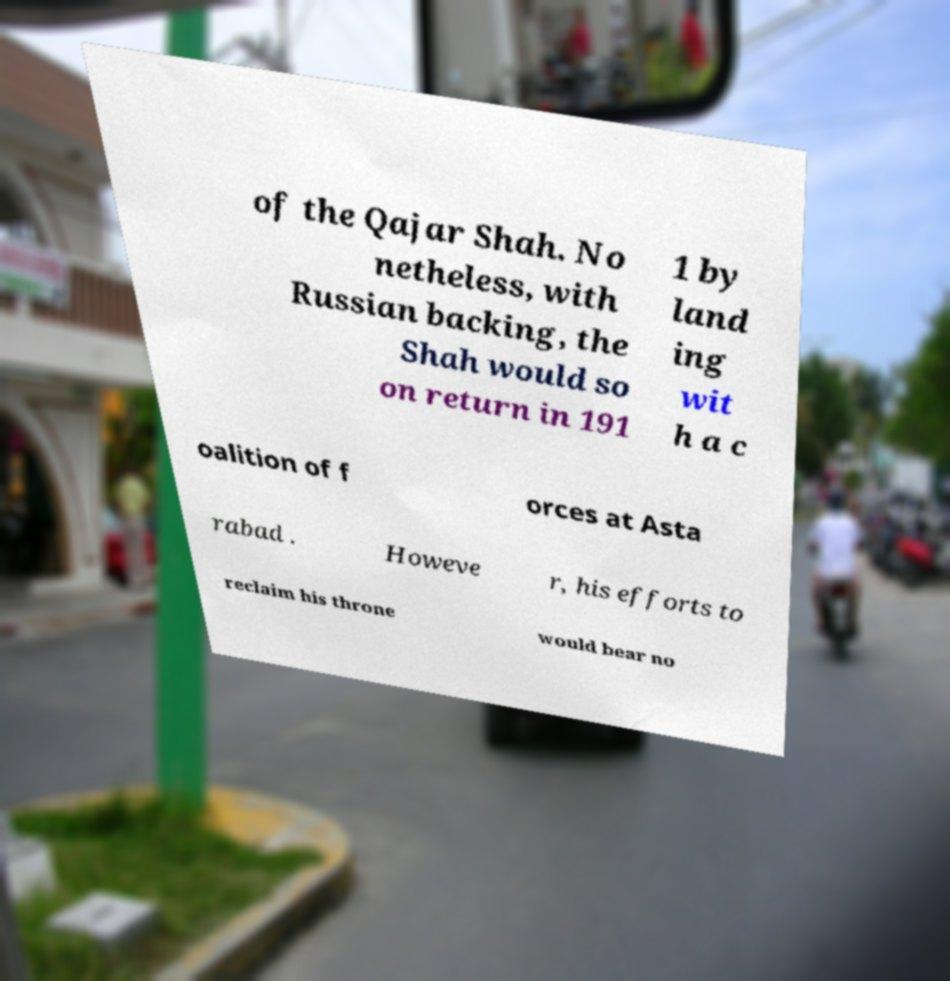Please read and relay the text visible in this image. What does it say? of the Qajar Shah. No netheless, with Russian backing, the Shah would so on return in 191 1 by land ing wit h a c oalition of f orces at Asta rabad . Howeve r, his efforts to reclaim his throne would bear no 